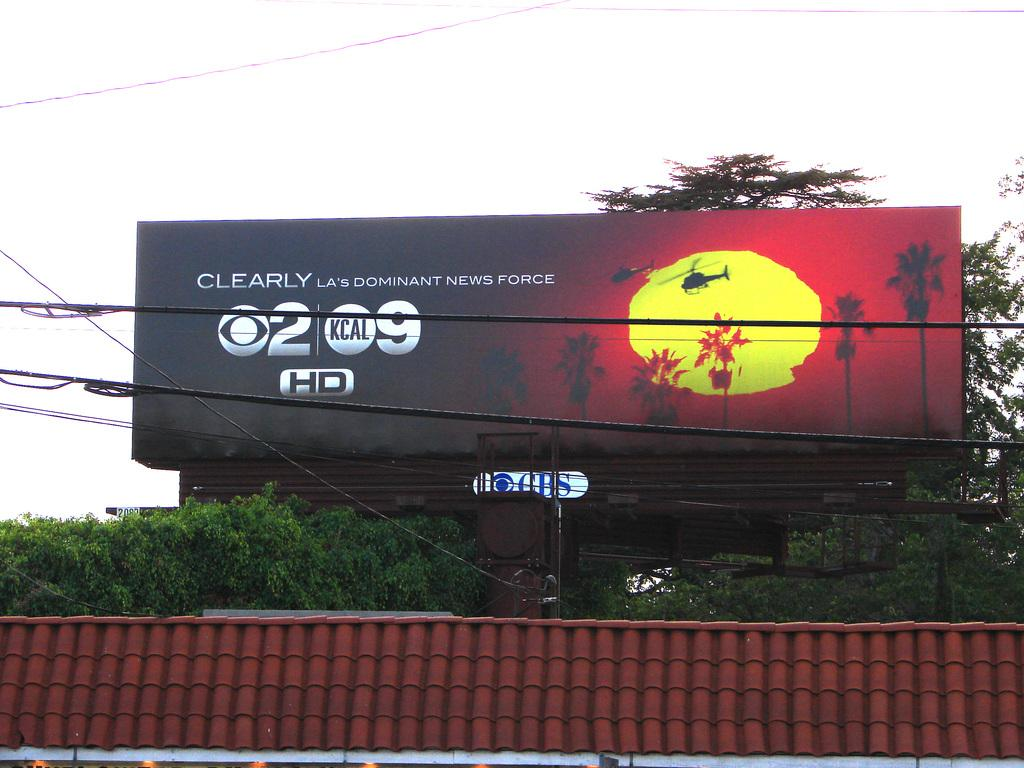<image>
Relay a brief, clear account of the picture shown. a billboard that says clearly LAs dominant news force 